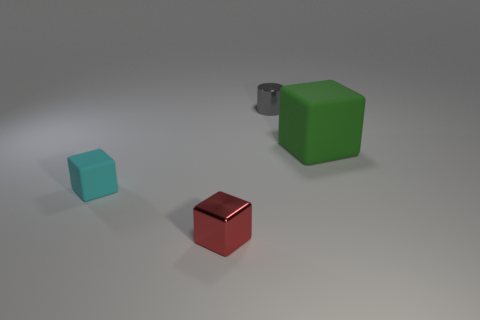What material is the red object that is the same shape as the large green thing?
Offer a very short reply. Metal. Are there any other things that are the same size as the green thing?
Offer a terse response. No. What color is the tiny metallic thing in front of the rubber object behind the tiny rubber object?
Make the answer very short. Red. The big object is what color?
Provide a short and direct response. Green. What number of objects are things on the left side of the big rubber cube or tiny red metal objects?
Make the answer very short. 3. Are there any tiny gray metal cylinders behind the cyan cube?
Your answer should be compact. Yes. Do the small thing that is in front of the tiny rubber thing and the cylinder have the same material?
Offer a terse response. Yes. Is there a large green object that is to the left of the matte thing that is left of the tiny metallic thing that is behind the red block?
Give a very brief answer. No. How many cylinders are either tiny objects or cyan rubber objects?
Provide a short and direct response. 1. There is a cube that is in front of the small cyan block; what material is it?
Your answer should be compact. Metal. 